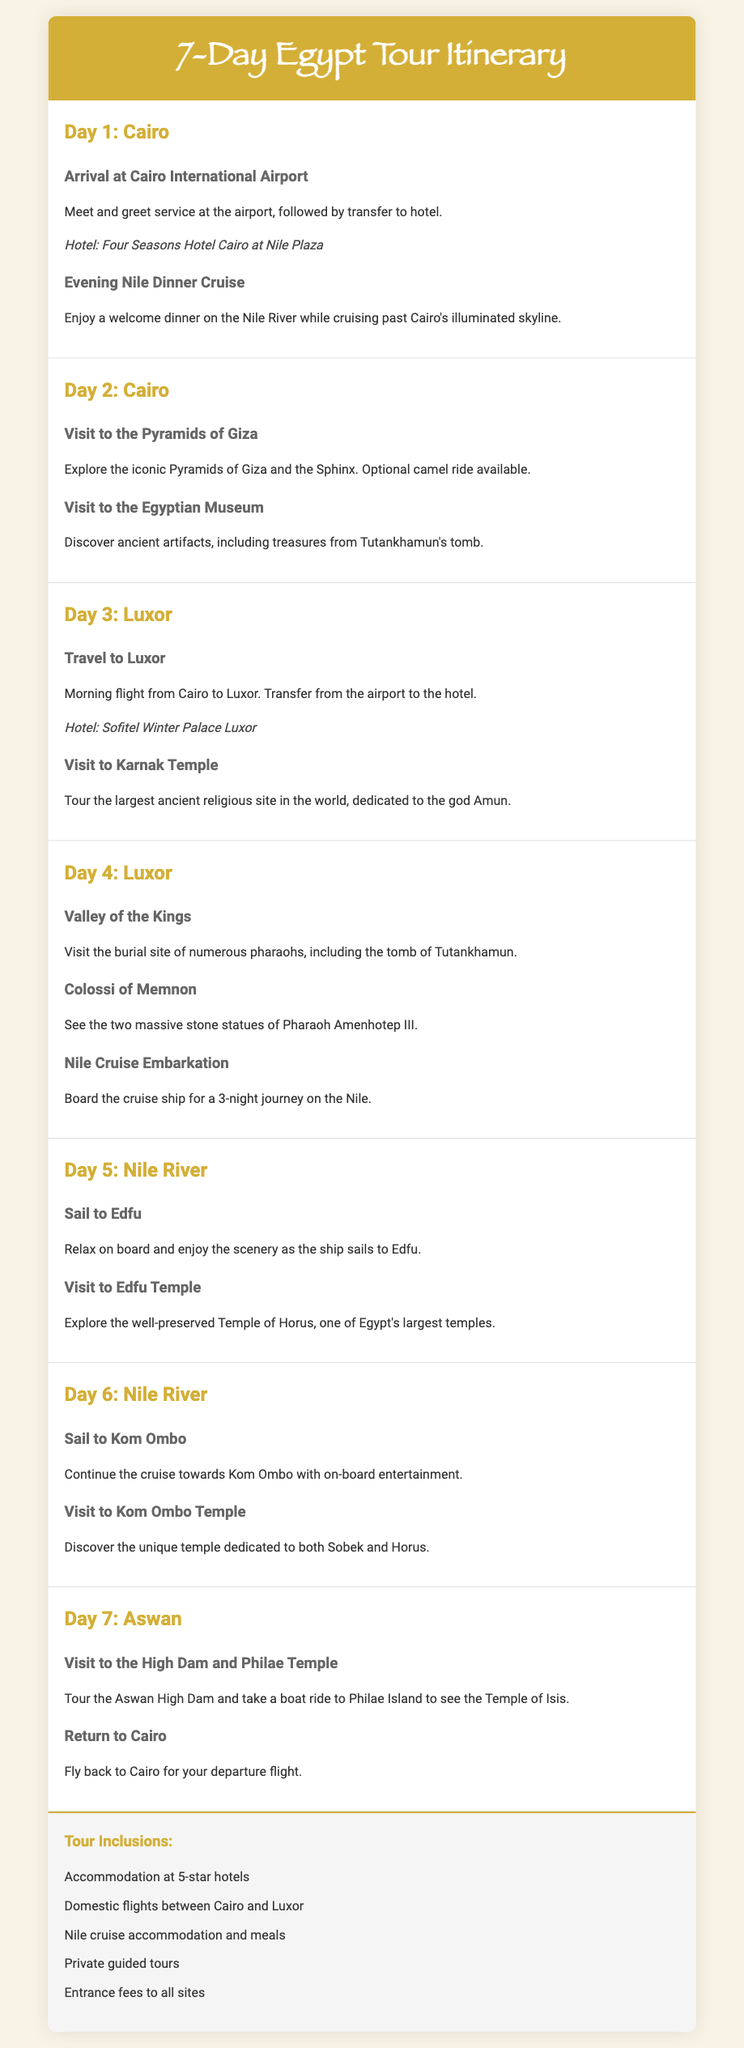what hotel is in Cairo? The document specifies the hotel for Cairo as "Four Seasons Hotel Cairo at Nile Plaza."
Answer: Four Seasons Hotel Cairo at Nile Plaza how many nights is the Nile cruise? The itinerary mentions a "3-night journey on the Nile."
Answer: 3 nights what is the first activity on Day 1? Day 1 starts with "Arrival at Cairo International Airport."
Answer: Arrival at Cairo International Airport what site is visited on Day 2? Day 2 includes a visit to "the Egyptian Museum."
Answer: the Egyptian Museum which temple is visited on Day 5? On Day 5, the itinerary specifies a visit to "Edfu Temple."
Answer: Edfu Temple what activity is planned for Day 6? Day 6 includes sailing to "Kom Ombo" and visiting its temple.
Answer: Sail to Kom Ombo how many days are included in the itinerary? The itinerary details activities for "7 days."
Answer: 7 days what type of tours are included in the package? The document states that "Private guided tours" are included in inclusions.
Answer: Private guided tours what is the departure location on Day 7? The itinerary indicates flying "back to Cairo for your departure flight."
Answer: back to Cairo 